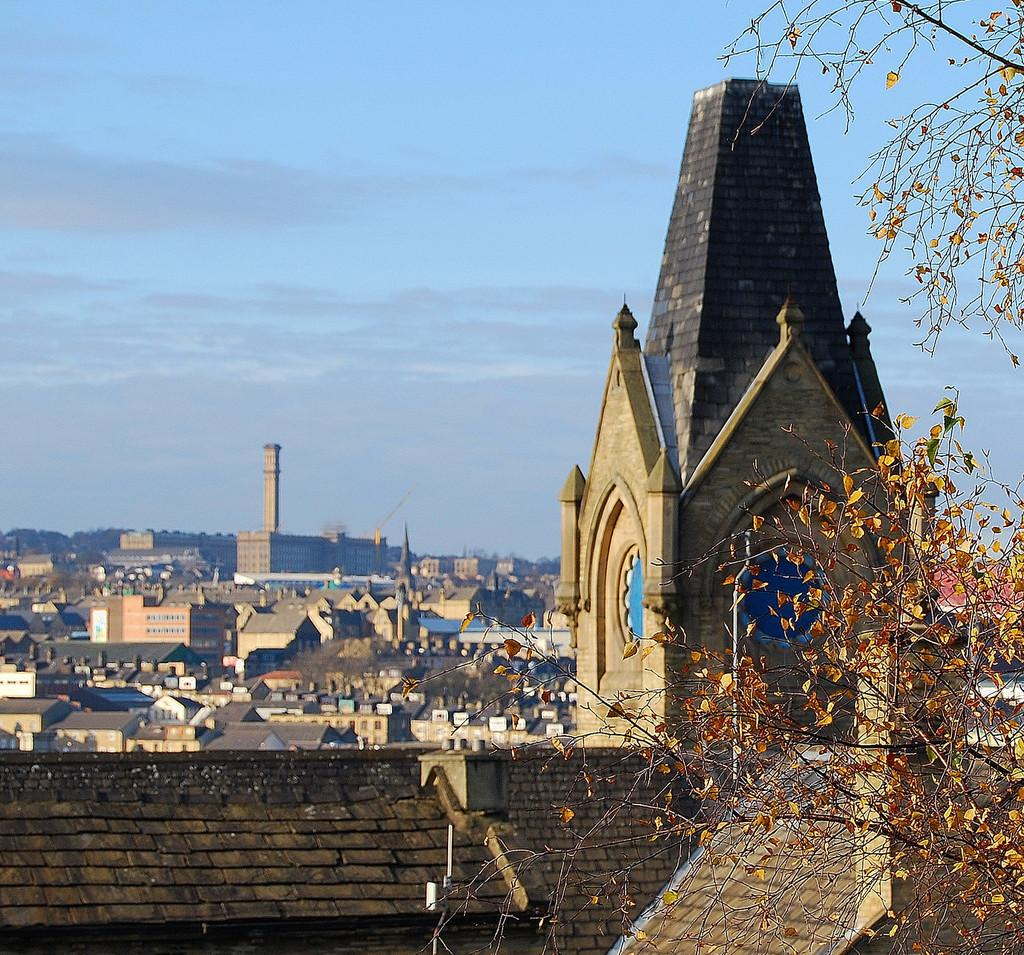What type of structures can be seen in the image? There are houses and buildings in the image. What type of vegetation is present in the image? There is a tree in the image. What is visible in the background of the image? The sky is visible in the image. What type of silk fabric is draped over the scene in the image? There is no silk fabric present in the image; it features houses, buildings, a tree, and the sky. 